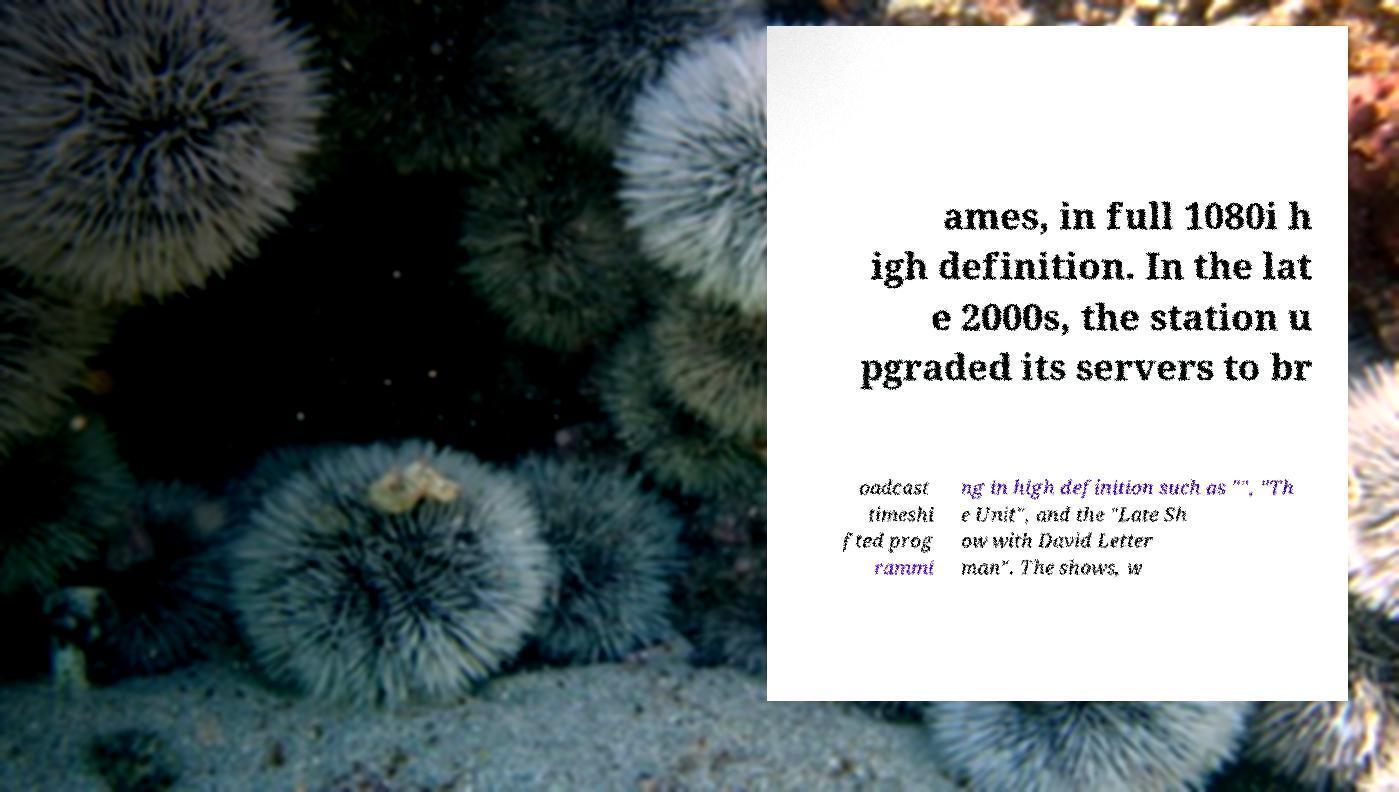Can you read and provide the text displayed in the image?This photo seems to have some interesting text. Can you extract and type it out for me? ames, in full 1080i h igh definition. In the lat e 2000s, the station u pgraded its servers to br oadcast timeshi fted prog rammi ng in high definition such as "", "Th e Unit", and the "Late Sh ow with David Letter man". The shows, w 